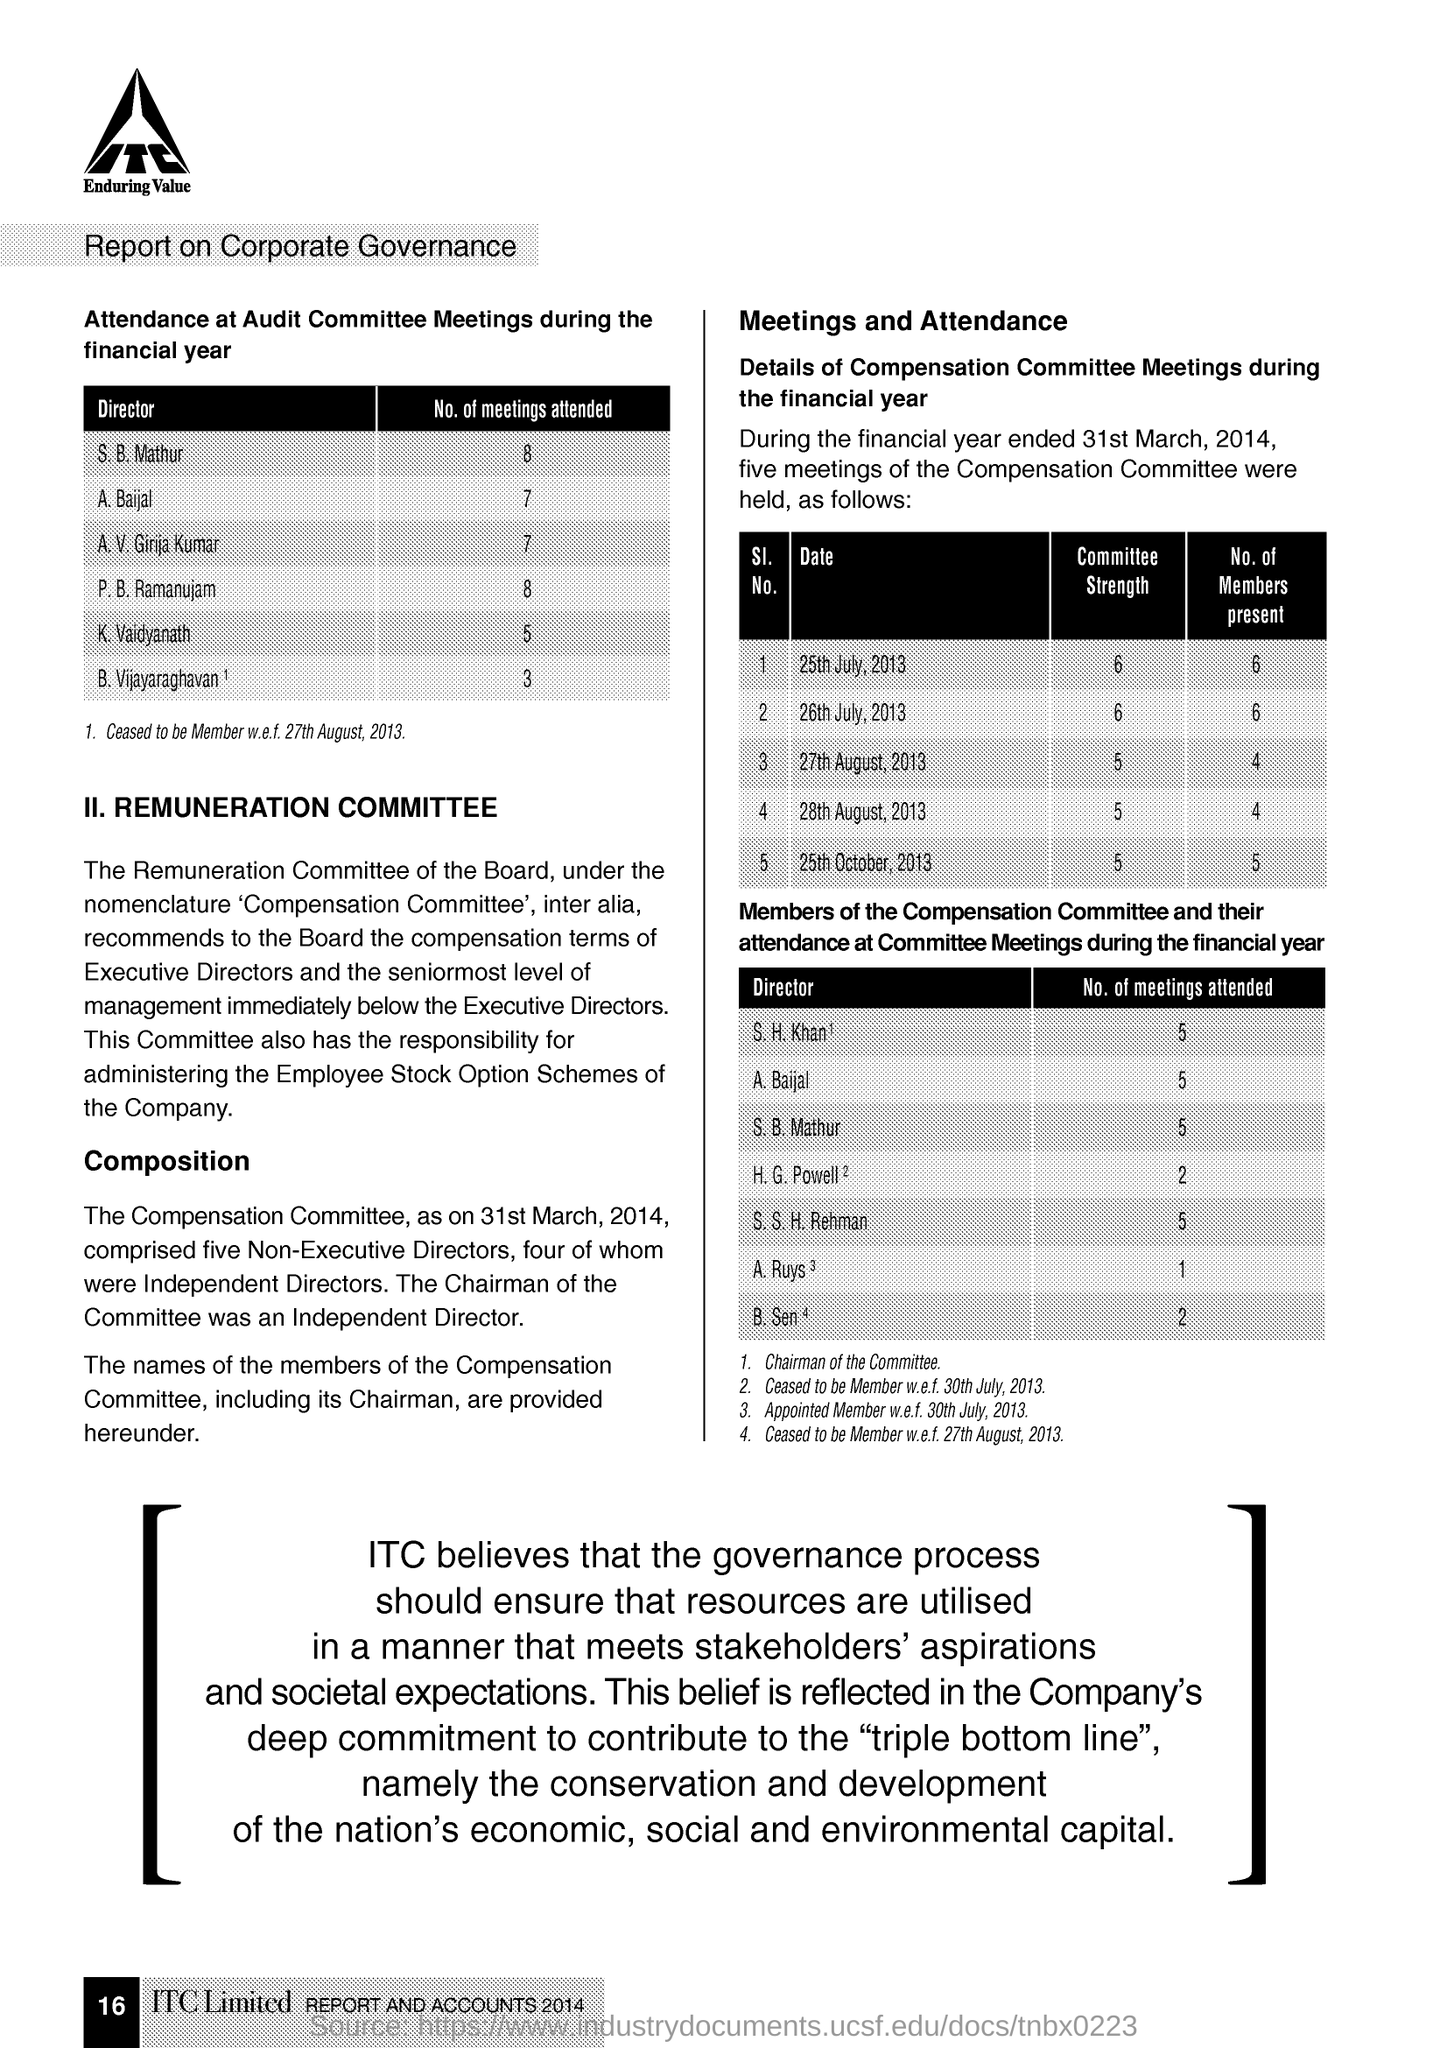Point out several critical features in this image. ITC Limited is mentioned in the document. 